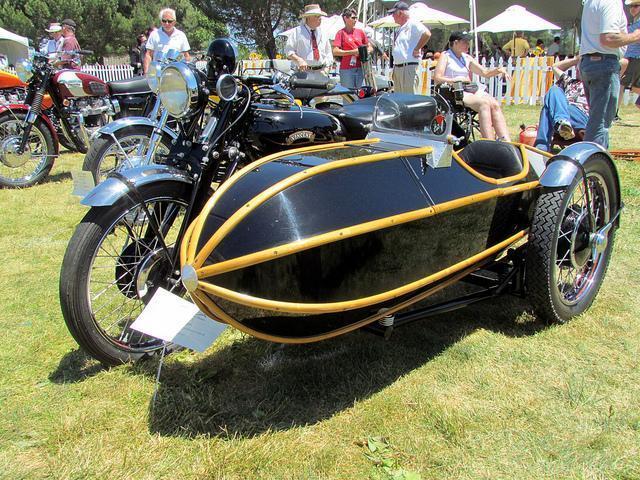How many motorcycles can you see?
Give a very brief answer. 3. How many people can you see?
Give a very brief answer. 5. 